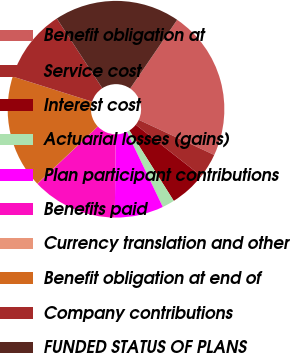Convert chart to OTSL. <chart><loc_0><loc_0><loc_500><loc_500><pie_chart><fcel>Benefit obligation at<fcel>Service cost<fcel>Interest cost<fcel>Actuarial losses (gains)<fcel>Plan participant contributions<fcel>Benefits paid<fcel>Currency translation and other<fcel>Benefit obligation at end of<fcel>Company contributions<fcel>FUNDED STATUS OF PLANS<nl><fcel>22.39%<fcel>3.65%<fcel>5.47%<fcel>1.84%<fcel>7.29%<fcel>12.74%<fcel>0.02%<fcel>16.94%<fcel>10.92%<fcel>18.75%<nl></chart> 